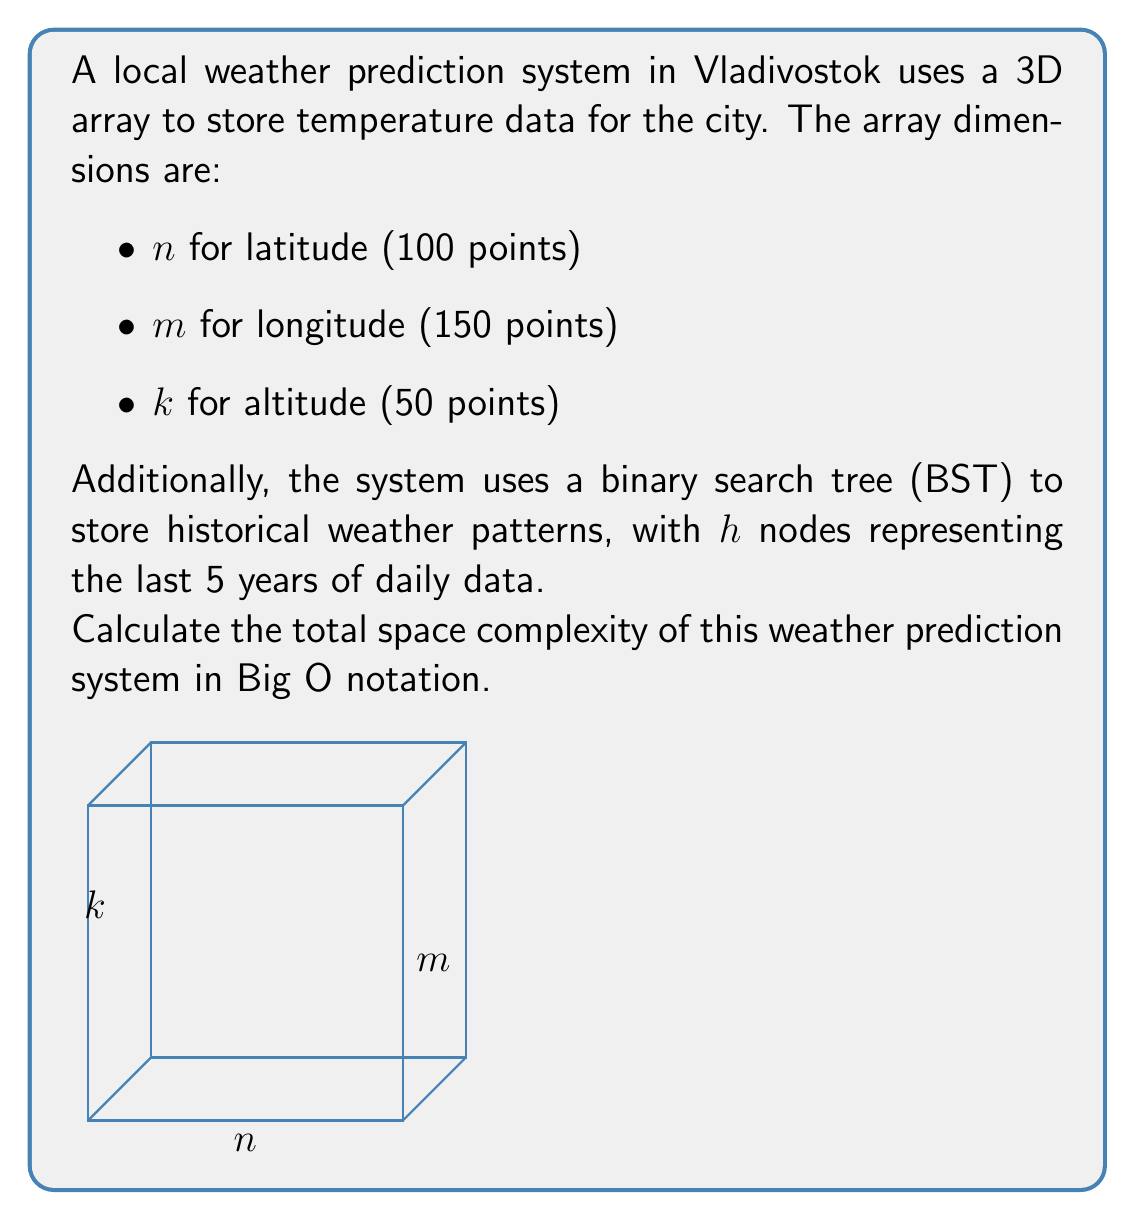Show me your answer to this math problem. Let's break down the space complexity analysis step-by-step:

1) 3D Array for temperature data:
   - The array has dimensions $n \times m \times k$
   - Total elements = $100 \times 150 \times 50 = 750,000$
   - Space complexity: $O(nmk)$

2) Binary Search Tree (BST) for historical data:
   - $h$ nodes representing 5 years of daily data
   - $h = 5 \text{ years} \times 365 \text{ days} = 1,825$ nodes
   - Space complexity of a BST: $O(h)$

3) Total space complexity:
   - Sum of the complexities of both data structures
   - $O(nmk) + O(h)$

4) Simplifying:
   - Since $nmk$ (750,000) is significantly larger than $h$ (1,825)
   - We can simplify to $O(nmk)$

Therefore, the dominant factor in the space complexity is the 3D array, and we can express the total space complexity as $O(nmk)$.
Answer: $O(nmk)$ 